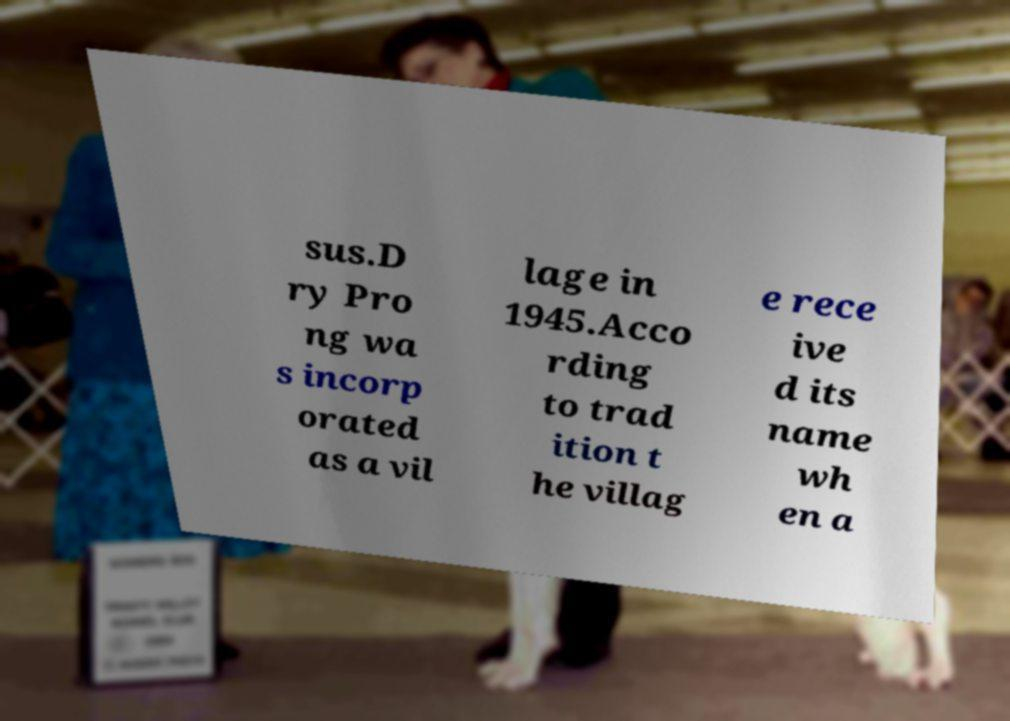Can you accurately transcribe the text from the provided image for me? sus.D ry Pro ng wa s incorp orated as a vil lage in 1945.Acco rding to trad ition t he villag e rece ive d its name wh en a 